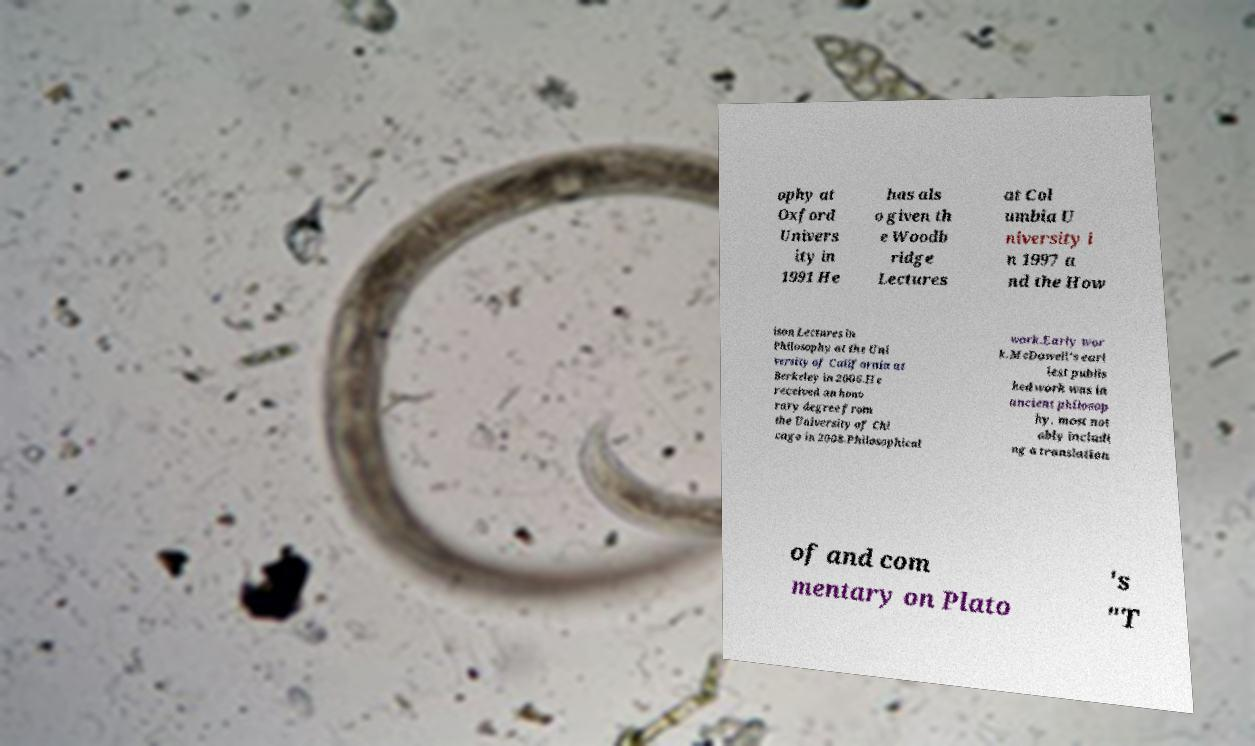Please identify and transcribe the text found in this image. ophy at Oxford Univers ity in 1991 He has als o given th e Woodb ridge Lectures at Col umbia U niversity i n 1997 a nd the How ison Lectures in Philosophy at the Uni versity of California at Berkeley in 2006.He received an hono rary degree from the University of Chi cago in 2008.Philosophical work.Early wor k.McDowell's earl iest publis hed work was in ancient philosop hy, most not ably includi ng a translation of and com mentary on Plato 's "T 